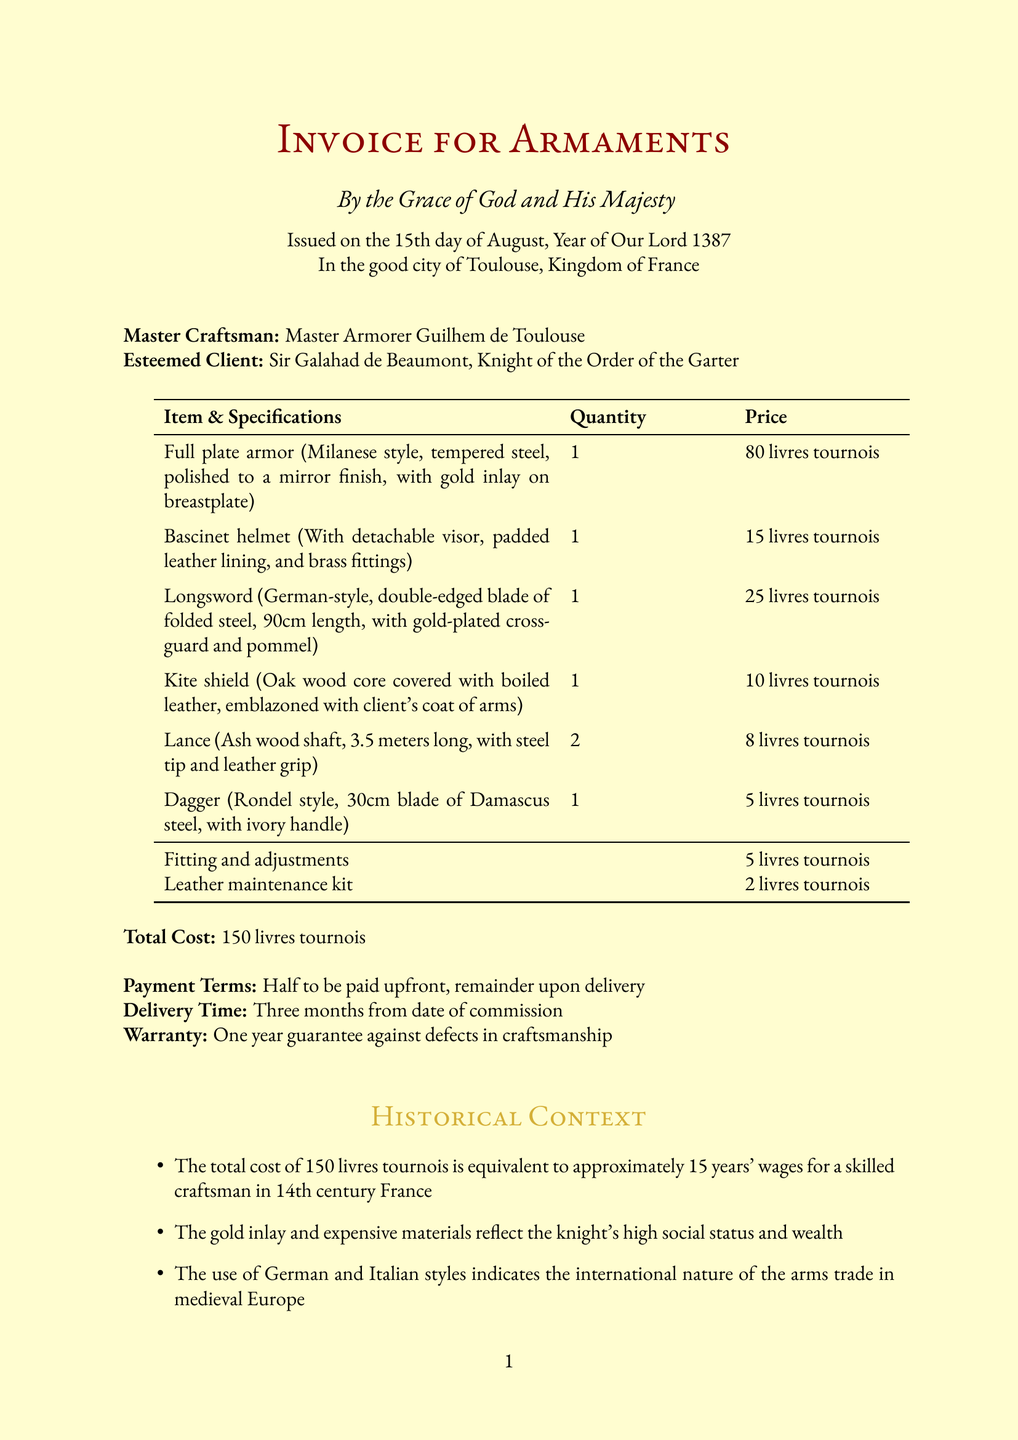What is the date of the invoice? The date of the invoice is stated in the document as "15th day of August, Year of Our Lord 1387."
Answer: 15th day of August, Year of Our Lord 1387 Who is the craftsman? The craftsman is identified as "Master Armorer Guilhem de Toulouse."
Answer: Master Armorer Guilhem de Toulouse How many items are listed in the invoice? The invoice lists a total of six items.
Answer: 6 What is the total cost? The total cost represents the sum of all items and services, which is given as "150 livres tournois."
Answer: 150 livres tournois What is the payment term? The document specifies that the payment terms are "Half to be paid upfront, remainder upon delivery."
Answer: Half to be paid upfront, remainder upon delivery How long is the delivery time? The delivery time mentioned in the document is "Three months from date of commission."
Answer: Three months What type of warranty is provided? The warranty stated in the document is "One year guarantee against defects in craftsmanship."
Answer: One year guarantee against defects in craftsmanship What is the quantity of lances ordered? The quantity of lances ordered is noted in the invoice as "2."
Answer: 2 What does the gold inlay signify? The gold inlay reflects the knight's status and wealth, as highlighted in the historical context.
Answer: High social status and wealth 